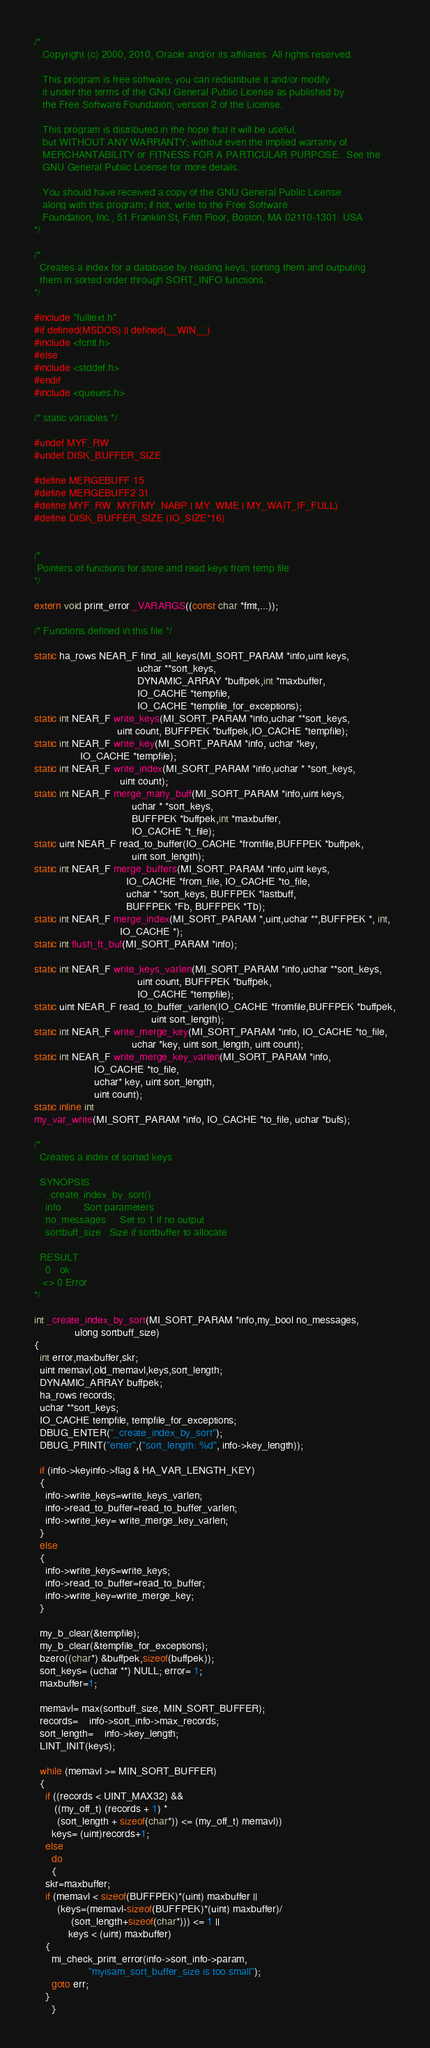Convert code to text. <code><loc_0><loc_0><loc_500><loc_500><_C_>/*
   Copyright (c) 2000, 2010, Oracle and/or its affiliates. All rights reserved.

   This program is free software; you can redistribute it and/or modify
   it under the terms of the GNU General Public License as published by
   the Free Software Foundation; version 2 of the License.

   This program is distributed in the hope that it will be useful,
   but WITHOUT ANY WARRANTY; without even the implied warranty of
   MERCHANTABILITY or FITNESS FOR A PARTICULAR PURPOSE.  See the
   GNU General Public License for more details.

   You should have received a copy of the GNU General Public License
   along with this program; if not, write to the Free Software
   Foundation, Inc., 51 Franklin St, Fifth Floor, Boston, MA 02110-1301  USA
*/

/*
  Creates a index for a database by reading keys, sorting them and outputing
  them in sorted order through SORT_INFO functions.
*/

#include "fulltext.h"
#if defined(MSDOS) || defined(__WIN__)
#include <fcntl.h>
#else
#include <stddef.h>
#endif
#include <queues.h>

/* static variables */

#undef MYF_RW
#undef DISK_BUFFER_SIZE

#define MERGEBUFF 15
#define MERGEBUFF2 31
#define MYF_RW  MYF(MY_NABP | MY_WME | MY_WAIT_IF_FULL)
#define DISK_BUFFER_SIZE (IO_SIZE*16)


/*
 Pointers of functions for store and read keys from temp file
*/

extern void print_error _VARARGS((const char *fmt,...));

/* Functions defined in this file */

static ha_rows NEAR_F find_all_keys(MI_SORT_PARAM *info,uint keys,
                                    uchar **sort_keys,
                                    DYNAMIC_ARRAY *buffpek,int *maxbuffer,
                                    IO_CACHE *tempfile,
                                    IO_CACHE *tempfile_for_exceptions);
static int NEAR_F write_keys(MI_SORT_PARAM *info,uchar **sort_keys,
                             uint count, BUFFPEK *buffpek,IO_CACHE *tempfile);
static int NEAR_F write_key(MI_SORT_PARAM *info, uchar *key,
			    IO_CACHE *tempfile);
static int NEAR_F write_index(MI_SORT_PARAM *info,uchar * *sort_keys,
                              uint count);
static int NEAR_F merge_many_buff(MI_SORT_PARAM *info,uint keys,
                                  uchar * *sort_keys,
                                  BUFFPEK *buffpek,int *maxbuffer,
                                  IO_CACHE *t_file);
static uint NEAR_F read_to_buffer(IO_CACHE *fromfile,BUFFPEK *buffpek,
                                  uint sort_length);
static int NEAR_F merge_buffers(MI_SORT_PARAM *info,uint keys,
                                IO_CACHE *from_file, IO_CACHE *to_file,
                                uchar * *sort_keys, BUFFPEK *lastbuff,
                                BUFFPEK *Fb, BUFFPEK *Tb);
static int NEAR_F merge_index(MI_SORT_PARAM *,uint,uchar **,BUFFPEK *, int,
                              IO_CACHE *);
static int flush_ft_buf(MI_SORT_PARAM *info);

static int NEAR_F write_keys_varlen(MI_SORT_PARAM *info,uchar **sort_keys,
                                    uint count, BUFFPEK *buffpek,
                                    IO_CACHE *tempfile);
static uint NEAR_F read_to_buffer_varlen(IO_CACHE *fromfile,BUFFPEK *buffpek,
                                         uint sort_length);
static int NEAR_F write_merge_key(MI_SORT_PARAM *info, IO_CACHE *to_file,
                                  uchar *key, uint sort_length, uint count);
static int NEAR_F write_merge_key_varlen(MI_SORT_PARAM *info,
					 IO_CACHE *to_file,
					 uchar* key, uint sort_length,
					 uint count);
static inline int
my_var_write(MI_SORT_PARAM *info, IO_CACHE *to_file, uchar *bufs);

/*
  Creates a index of sorted keys

  SYNOPSIS
    _create_index_by_sort()
    info		Sort parameters
    no_messages		Set to 1 if no output
    sortbuff_size	Size if sortbuffer to allocate

  RESULT
    0	ok
   <> 0 Error
*/

int _create_index_by_sort(MI_SORT_PARAM *info,my_bool no_messages,
			  ulong sortbuff_size)
{
  int error,maxbuffer,skr;
  uint memavl,old_memavl,keys,sort_length;
  DYNAMIC_ARRAY buffpek;
  ha_rows records;
  uchar **sort_keys;
  IO_CACHE tempfile, tempfile_for_exceptions;
  DBUG_ENTER("_create_index_by_sort");
  DBUG_PRINT("enter",("sort_length: %d", info->key_length));

  if (info->keyinfo->flag & HA_VAR_LENGTH_KEY)
  {
    info->write_keys=write_keys_varlen;
    info->read_to_buffer=read_to_buffer_varlen;
    info->write_key= write_merge_key_varlen;
  }
  else
  {
    info->write_keys=write_keys;
    info->read_to_buffer=read_to_buffer;
    info->write_key=write_merge_key;
  }

  my_b_clear(&tempfile);
  my_b_clear(&tempfile_for_exceptions);
  bzero((char*) &buffpek,sizeof(buffpek));
  sort_keys= (uchar **) NULL; error= 1;
  maxbuffer=1;

  memavl= max(sortbuff_size, MIN_SORT_BUFFER);
  records=	info->sort_info->max_records;
  sort_length=	info->key_length;
  LINT_INIT(keys);

  while (memavl >= MIN_SORT_BUFFER)
  {
    if ((records < UINT_MAX32) && 
       ((my_off_t) (records + 1) * 
        (sort_length + sizeof(char*)) <= (my_off_t) memavl))
      keys= (uint)records+1;
    else
      do
      {
	skr=maxbuffer;
	if (memavl < sizeof(BUFFPEK)*(uint) maxbuffer ||
	    (keys=(memavl-sizeof(BUFFPEK)*(uint) maxbuffer)/
             (sort_length+sizeof(char*))) <= 1 ||
            keys < (uint) maxbuffer)
	{
	  mi_check_print_error(info->sort_info->param,
			       "myisam_sort_buffer_size is too small");
	  goto err;
	}
      }</code> 